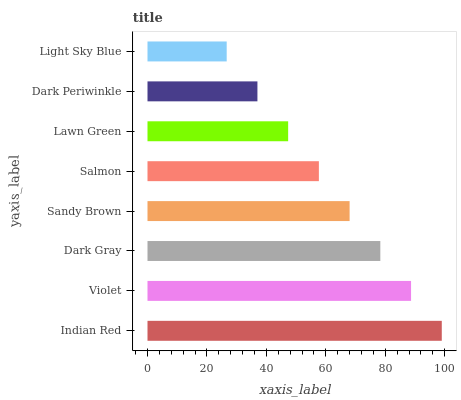Is Light Sky Blue the minimum?
Answer yes or no. Yes. Is Indian Red the maximum?
Answer yes or no. Yes. Is Violet the minimum?
Answer yes or no. No. Is Violet the maximum?
Answer yes or no. No. Is Indian Red greater than Violet?
Answer yes or no. Yes. Is Violet less than Indian Red?
Answer yes or no. Yes. Is Violet greater than Indian Red?
Answer yes or no. No. Is Indian Red less than Violet?
Answer yes or no. No. Is Sandy Brown the high median?
Answer yes or no. Yes. Is Salmon the low median?
Answer yes or no. Yes. Is Dark Gray the high median?
Answer yes or no. No. Is Sandy Brown the low median?
Answer yes or no. No. 